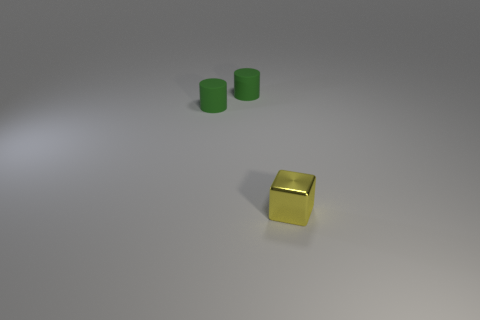Add 2 matte spheres. How many objects exist? 5 Subtract all cylinders. How many objects are left? 1 Add 1 small blocks. How many small blocks exist? 2 Subtract 0 yellow balls. How many objects are left? 3 Subtract all green things. Subtract all yellow metallic cubes. How many objects are left? 0 Add 3 green things. How many green things are left? 5 